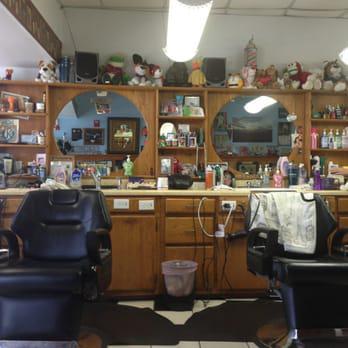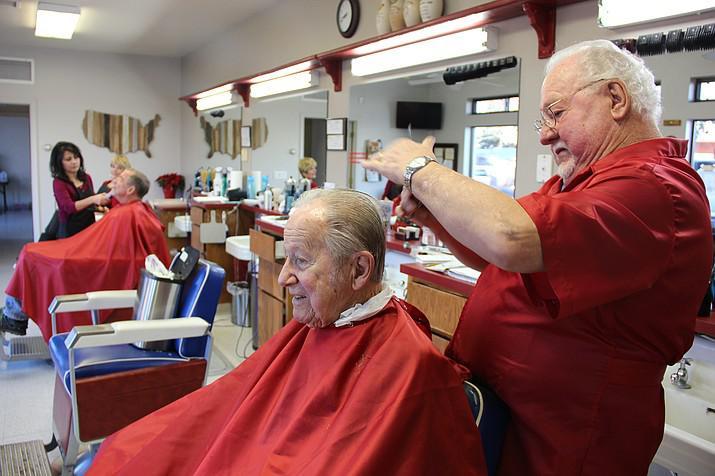The first image is the image on the left, the second image is the image on the right. For the images displayed, is the sentence "The foreground of one image features a woman in a black apron standing behind a leftward facing male wearing a smock." factually correct? Answer yes or no. No. The first image is the image on the left, the second image is the image on the right. Examine the images to the left and right. Is the description "In one image, a male and a female barber are both working on seated customers, with an empty chair between them." accurate? Answer yes or no. Yes. 